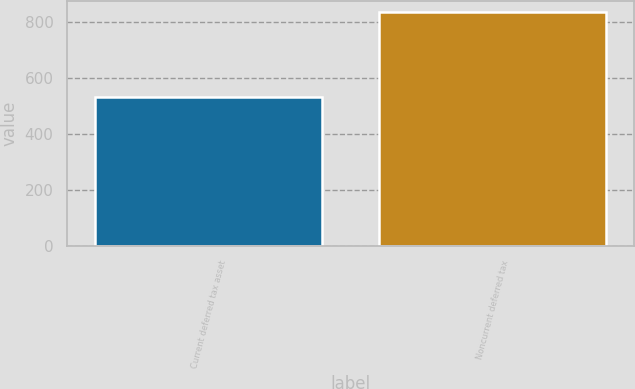Convert chart to OTSL. <chart><loc_0><loc_0><loc_500><loc_500><bar_chart><fcel>Current deferred tax asset<fcel>Noncurrent deferred tax<nl><fcel>533<fcel>836<nl></chart> 